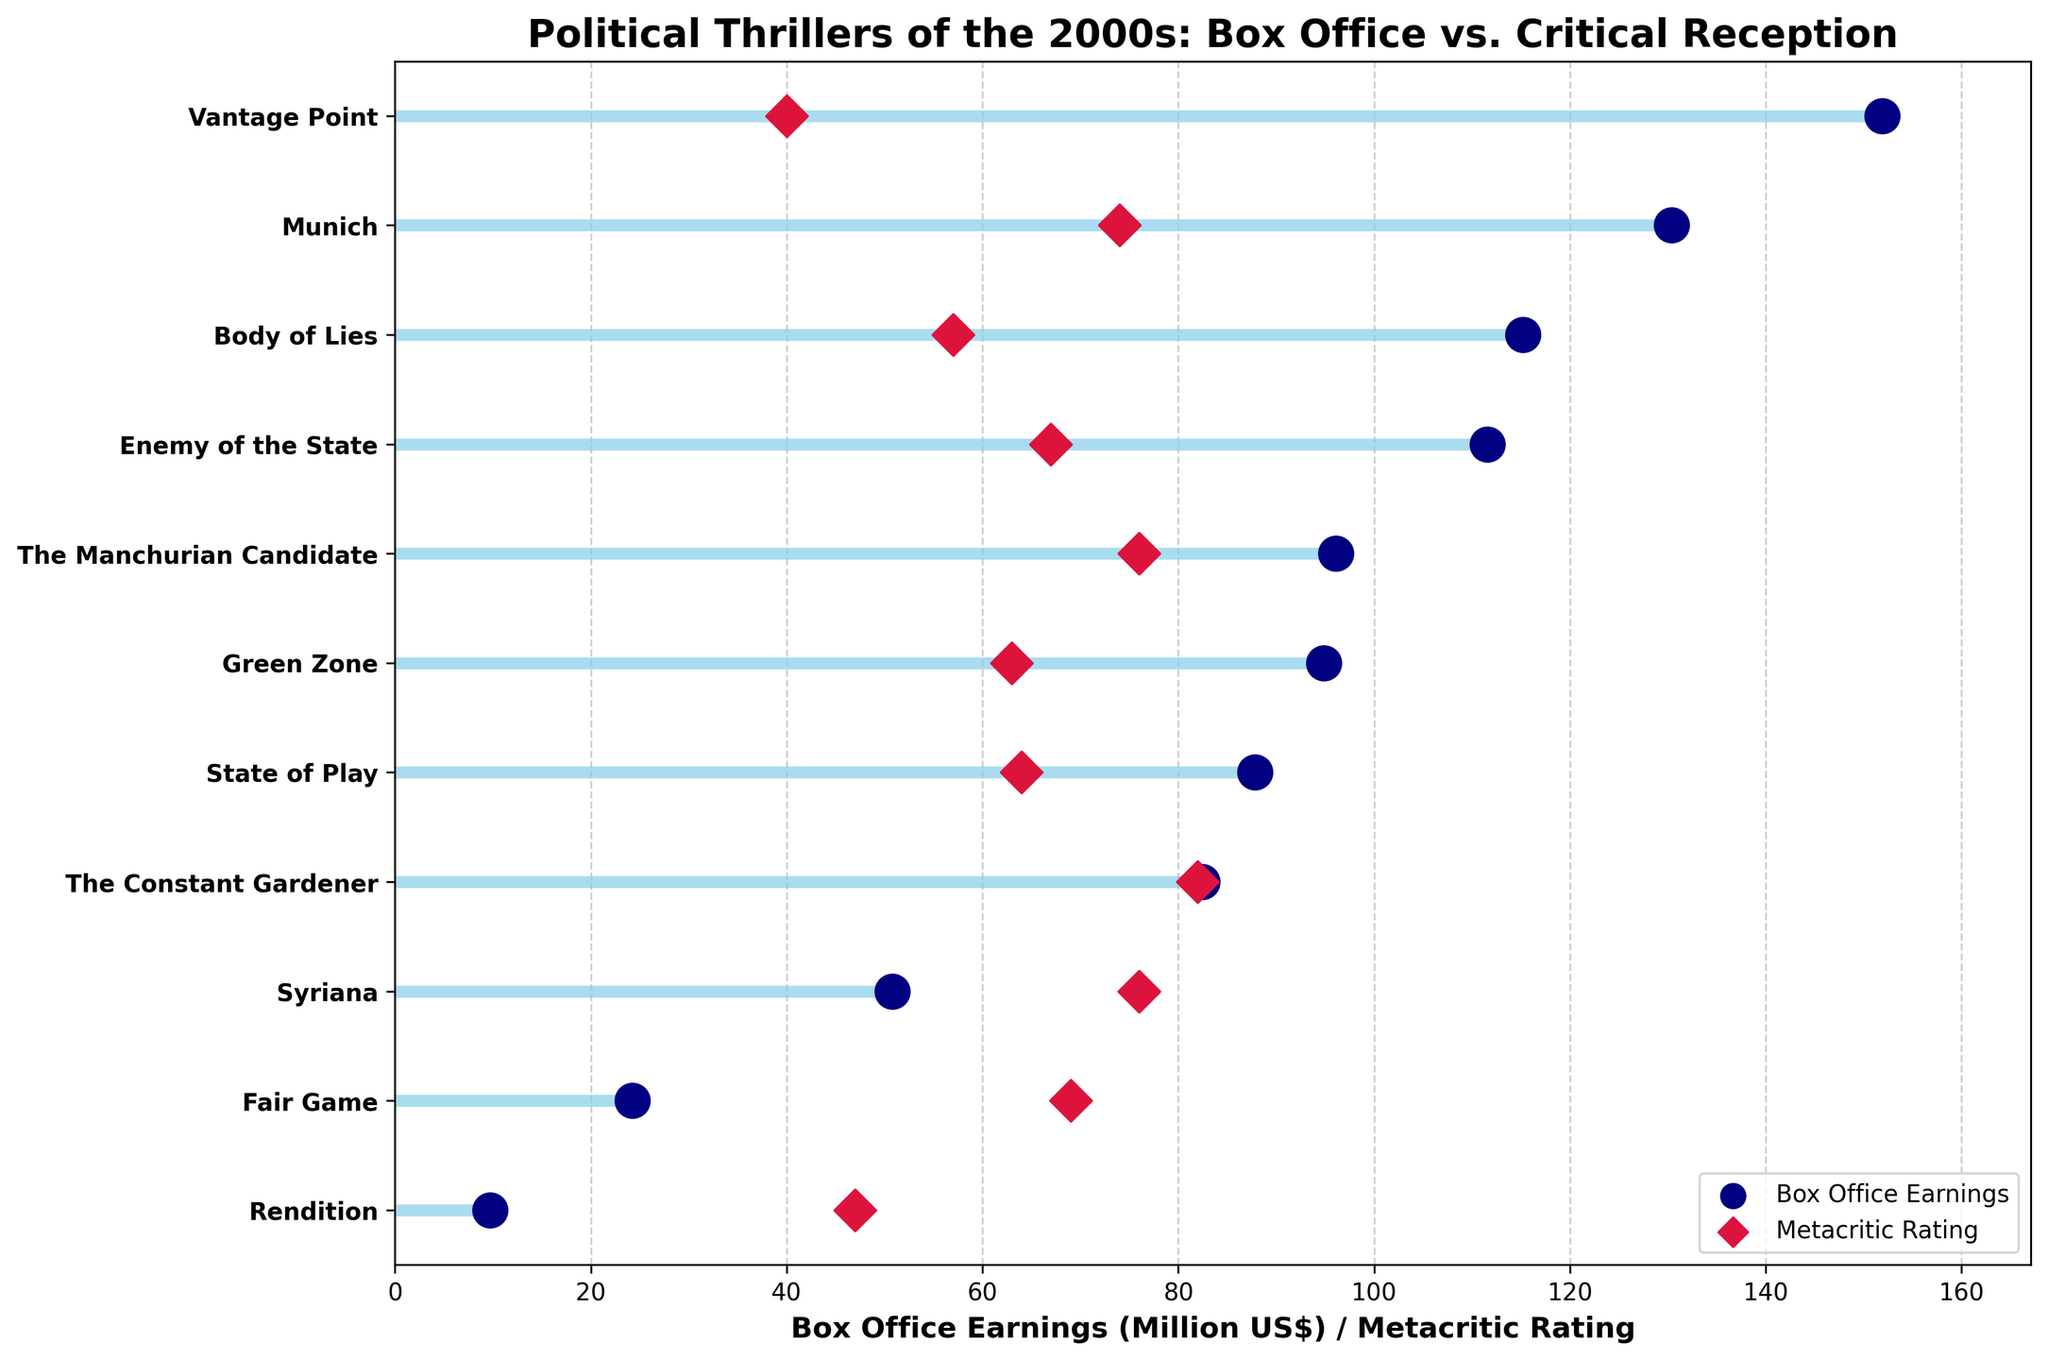Which movie has the highest box office earnings? Identify which movie has the furthest dot from the origin on the horizontal axis dedicated to box office earnings.
Answer: Vantage Point What is the title of the plot? Read the text at the top center of the figure.
Answer: Political Thrillers of the 2000s: Box Office vs. Critical Reception Which movie has the lowest critical rating? Identify the movie corresponding to the lowest point on the Metacritic rating scale.
Answer: Vantage Point What's the difference in box office earnings between the highest and the lowest earning movie? Subtract the box office earnings of "Rendition" (9.73 million US$) from "Vantage Point" (151.90 million US$).
Answer: 142.17 million US$ How many movies have a Metacritic rating above 70? Count all the movies with their dots on the Metacritic rating scale greater than 70.
Answer: 4 Which movie has a higher Metacritic rating, "Syriana" or "The Constant Gardener"? Compare the Metacritic ratings of both movies on the horizontal axis.
Answer: The Constant Gardener Does higher box office earnings correlate with higher Metacritic ratings in this dataset? Analyze the positioning of the dots; high box office earnings do not consistently align with high Metacritic ratings.
Answer: No How much more did "Body of Lies" earn compared to "Fair Game"? Subtract the box office earnings of "Fair Game" from "Body of Lies".
Answer: 90.93 million US$ Which two movies have equal Metacritic ratings? Identify two movies with dots at the same position on the Metacritic rating scale.
Answer: Syriana and The Manchurian Candidate What is the average Metacritic rating of all the movies in the plot? Add up all the Metacritic ratings and divide by the number of movies.
Answer: 64.36 